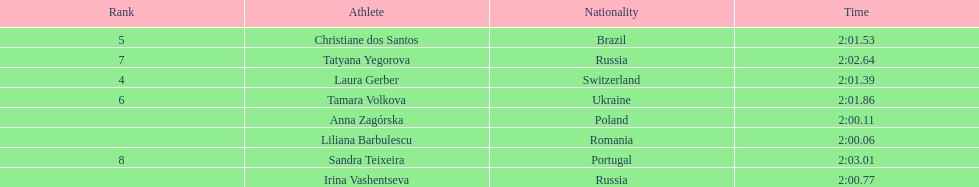What is the name of the top finalist of this semifinals heat? Liliana Barbulescu. 